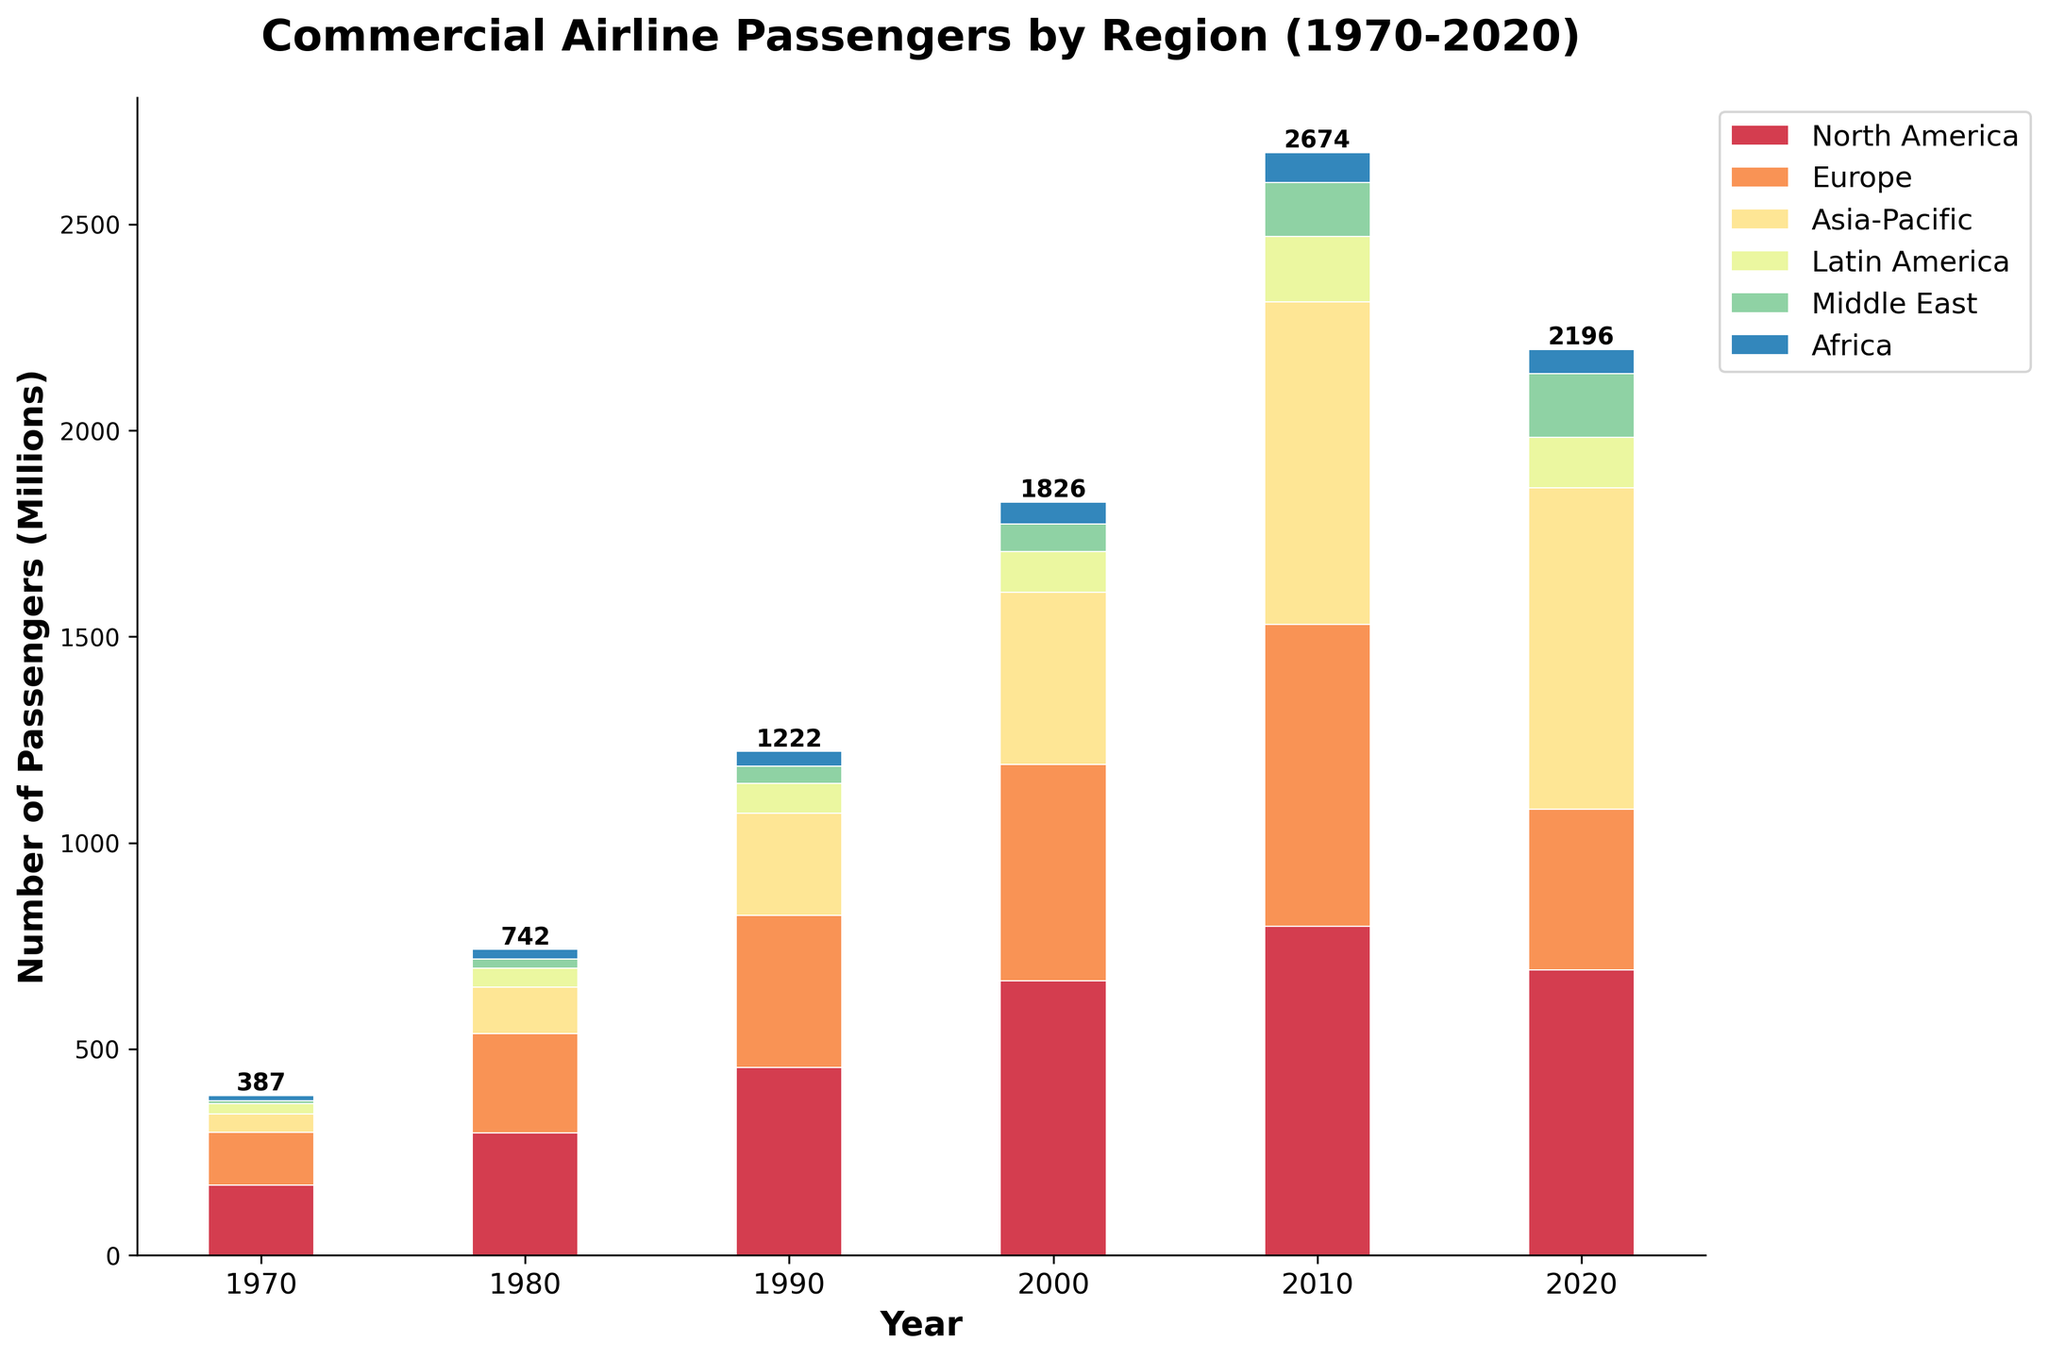What's the total number of commercial airline passengers in 2020 across all regions? Look at the values for each region in 2020, then sum them: 692 (North America) + 389 (Europe) + 780 (Asia-Pacific) + 123 (Latin America) + 154 (Middle East) + 58 (Africa) = 2196 million.
Answer: 2196 Which region experienced the largest growth in commercial airline passengers from 1970 to 2020? Subtract the number of passengers in 1970 from the number in 2020 for each region and find the region with the largest difference: North America (692-170=522), Europe (389-128=261), Asia-Pacific (780-45=735), Latin America (123-24=99), Middle East (154-8=146), Africa (58-12=46). Asia-Pacific has the largest growth of 735 million.
Answer: Asia-Pacific By how much did the number of commercial airline passengers in Europe increase from 1970 to 2000? Subtract the number of passengers in 1970 from the number in 2000: 524 (2000) - 128 (1970) = 396 million.
Answer: 396 Which two regions had the most comparable number of passengers in 2020 and how do their numbers compare? Look at the number of passengers for each region in 2020: North America (692), Europe (389), Asia-Pacific (780), Latin America (123), Middle East (154), Africa (58). Middle East (154) and Latin America (123) are closest, and Middle East is 31 million more than Latin America.
Answer: Middle East and Latin America, Middle East is 31 million more What is the visual difference in height between the bars representing North America and Europe in 2010? In 2010, North America's bar reaches 798 million whereas Europe's bar is at 732 million. North America's bar is visually higher by 66 million.
Answer: 66 million Which year shows the highest total number of commercial airline passengers across all regions? Add the total number of passengers for all regions across each year and compare: 1970 (387), 1980 (742), 1990 (1222), 2000 (1826), 2010 (2674), 2020 (2196). The year 2010 has the highest total of 2674 million passengers.
Answer: 2010 Between 2000 and 2020, which region showed a decline in the number of passengers? Subtract the number of passengers in 2000 from the number in 2020 for each region: North America (692-666=-4), Europe (389-524=-135), Asia-Pacific (780-418=362), Latin America (123-98=25), Middle East (154-68=86), Africa (58-52=6). Europe saw a decline of 135 million passengers.
Answer: Europe How does the number of passengers in Asia-Pacific in 2020 compare to the combined number of passengers in North America and Europe in 1980? The number of passengers in Asia-Pacific in 2020 is 780 million. The combined number in North America (296) and Europe (242) in 1980 is 538 million. Asia-Pacific's 2020 passenger number is 242 million more than the combined 1980 figure for North America and Europe.
Answer: 242 million more Which region consistently shows growth across all the years depicted? Analyze the data for each region year by year. Asia-Pacific shows consistent growth from 45 (1970) to 112 (1980), 248 (1990), 418 (2000), 782 (2010), and 780 (2020).
Answer: Asia-Pacific How many more passengers did North America have compared to Africa in 1970? Subtract the number of passengers in Africa from the number in North America for 1970: 170 (North America) - 12 (Africa) = 158 million.
Answer: 158 million 